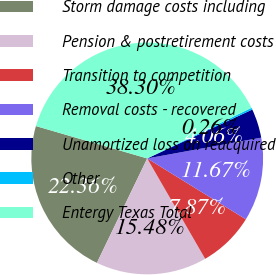Convert chart. <chart><loc_0><loc_0><loc_500><loc_500><pie_chart><fcel>Storm damage costs including<fcel>Pension & postretirement costs<fcel>Transition to competition<fcel>Removal costs - recovered<fcel>Unamortized loss on reacquired<fcel>Other<fcel>Entergy Texas Total<nl><fcel>22.36%<fcel>15.48%<fcel>7.87%<fcel>11.67%<fcel>4.06%<fcel>0.26%<fcel>38.3%<nl></chart> 